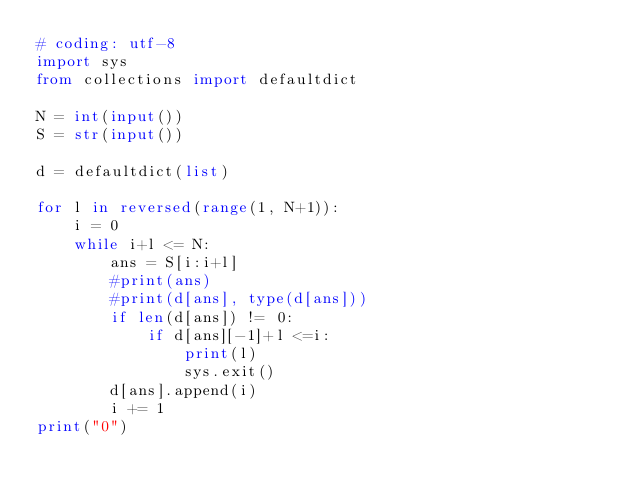<code> <loc_0><loc_0><loc_500><loc_500><_Python_># coding: utf-8
import sys
from collections import defaultdict

N = int(input())
S = str(input())

d = defaultdict(list)

for l in reversed(range(1, N+1)):
    i = 0
    while i+l <= N:
        ans = S[i:i+l]
        #print(ans)
        #print(d[ans], type(d[ans]))
        if len(d[ans]) != 0:
            if d[ans][-1]+l <=i:
                print(l)
                sys.exit()
        d[ans].append(i)
        i += 1
print("0")</code> 